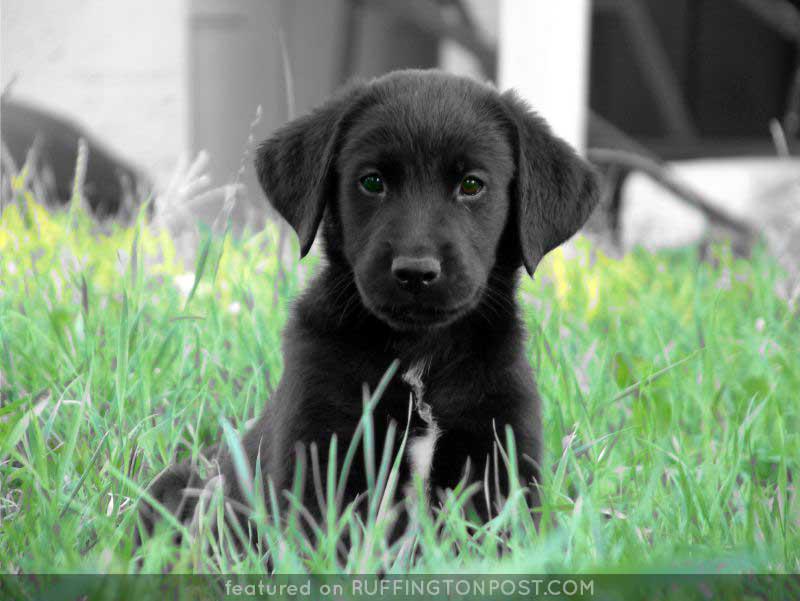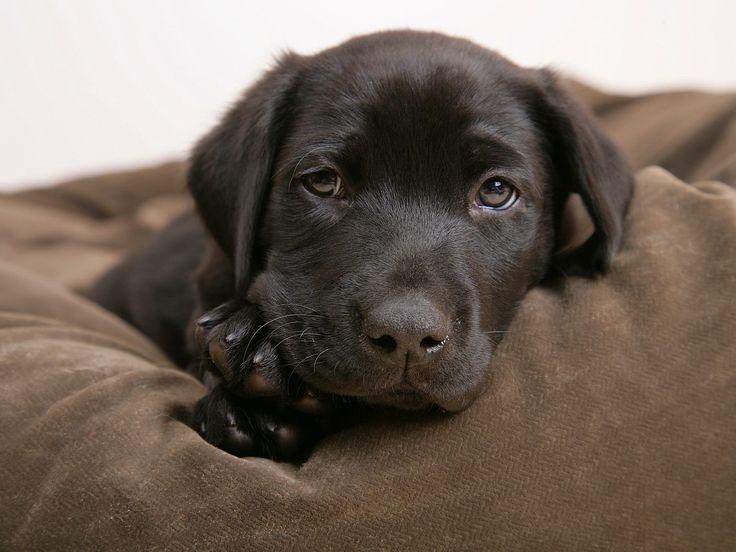The first image is the image on the left, the second image is the image on the right. Analyze the images presented: Is the assertion "there are two black puppies in the image pair" valid? Answer yes or no. Yes. The first image is the image on the left, the second image is the image on the right. Considering the images on both sides, is "Each image shows one forward-facing young dog, and the dogs in the left and right images have dark fur color." valid? Answer yes or no. Yes. 